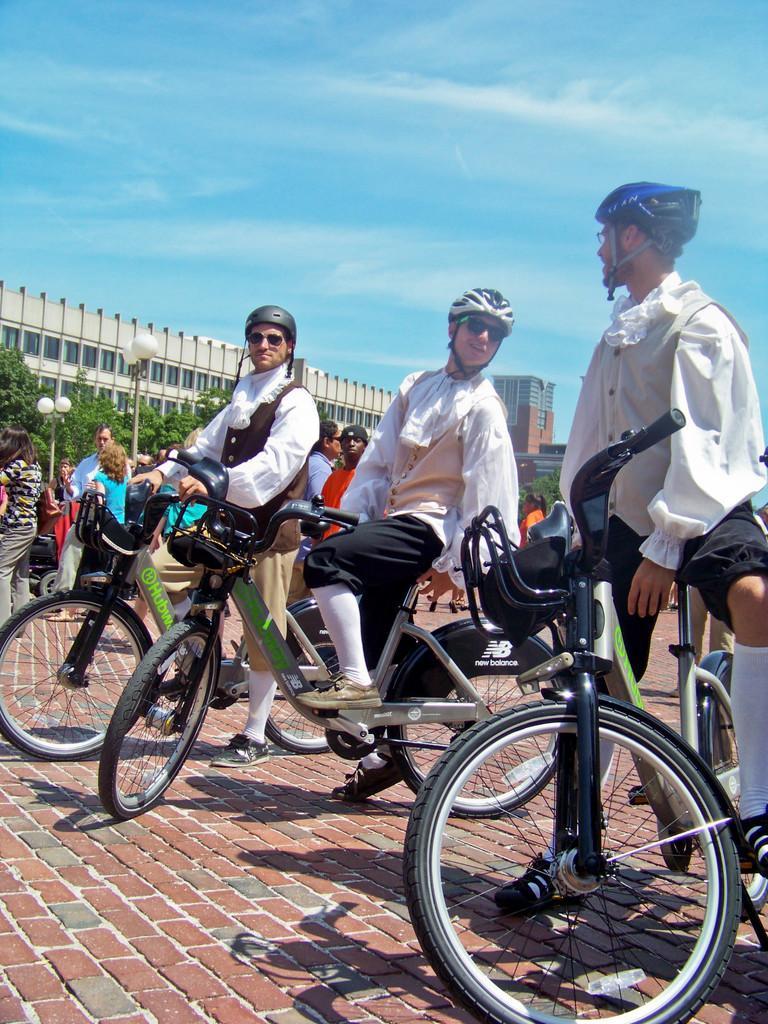In one or two sentences, can you explain what this image depicts? Few persons are standing. These three persons are sitting and holding bicycle. On the background we can see building,trees,pole,light,sky. These three persons wear helmet. 